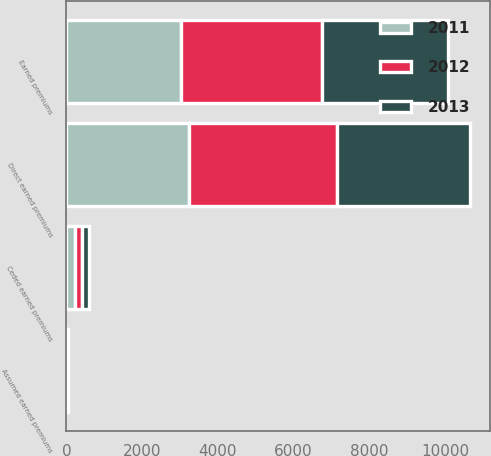Convert chart to OTSL. <chart><loc_0><loc_0><loc_500><loc_500><stacked_bar_chart><ecel><fcel>Direct earned premiums<fcel>Assumed earned premiums<fcel>Ceded earned premiums<fcel>Earned premiums<nl><fcel>2012<fcel>3903<fcel>11<fcel>201<fcel>3713<nl><fcel>2013<fcel>3520<fcel>9<fcel>185<fcel>3344<nl><fcel>2011<fcel>3236<fcel>12<fcel>219<fcel>3029<nl></chart> 